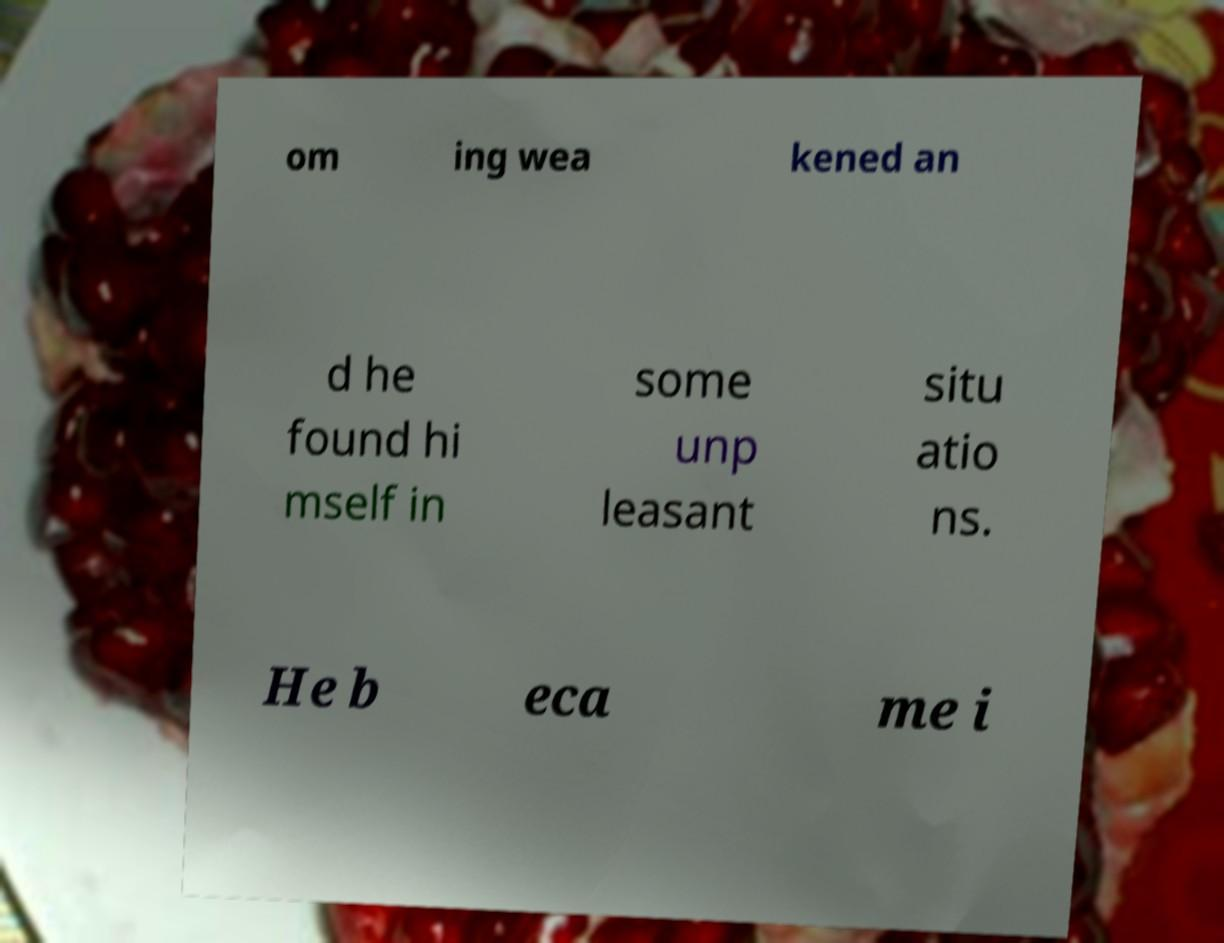I need the written content from this picture converted into text. Can you do that? om ing wea kened an d he found hi mself in some unp leasant situ atio ns. He b eca me i 